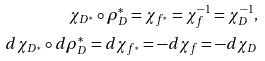Convert formula to latex. <formula><loc_0><loc_0><loc_500><loc_500>\chi _ { D ^ { * } } \circ \rho _ { D } ^ { * } = \chi _ { f ^ { * } } = \chi _ { f } ^ { - 1 } = \chi _ { D } ^ { - 1 } , \\ d \chi _ { D ^ { * } } \circ d \rho _ { D } ^ { * } = d \chi _ { f ^ { * } } = - d \chi _ { f } = - d \chi _ { D }</formula> 